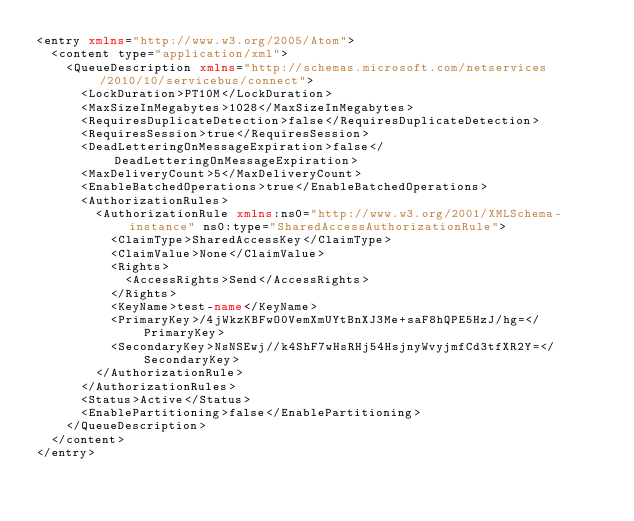<code> <loc_0><loc_0><loc_500><loc_500><_XML_><entry xmlns="http://www.w3.org/2005/Atom">
  <content type="application/xml">
    <QueueDescription xmlns="http://schemas.microsoft.com/netservices/2010/10/servicebus/connect">
      <LockDuration>PT10M</LockDuration>
      <MaxSizeInMegabytes>1028</MaxSizeInMegabytes>
      <RequiresDuplicateDetection>false</RequiresDuplicateDetection>
      <RequiresSession>true</RequiresSession>
      <DeadLetteringOnMessageExpiration>false</DeadLetteringOnMessageExpiration>
      <MaxDeliveryCount>5</MaxDeliveryCount>
      <EnableBatchedOperations>true</EnableBatchedOperations>
      <AuthorizationRules>
        <AuthorizationRule xmlns:ns0="http://www.w3.org/2001/XMLSchema-instance" ns0:type="SharedAccessAuthorizationRule">
          <ClaimType>SharedAccessKey</ClaimType>
          <ClaimValue>None</ClaimValue>
          <Rights>
            <AccessRights>Send</AccessRights>
          </Rights>
          <KeyName>test-name</KeyName>
          <PrimaryKey>/4jWkzKBFwO0VemXmUYtBnXJ3Me+saF8hQPE5HzJ/hg=</PrimaryKey>
          <SecondaryKey>NsNSEwj//k4ShF7wHsRHj54HsjnyWvyjmfCd3tfXR2Y=</SecondaryKey>
        </AuthorizationRule>
      </AuthorizationRules>
      <Status>Active</Status>
      <EnablePartitioning>false</EnablePartitioning>
    </QueueDescription>
  </content>
</entry>
</code> 